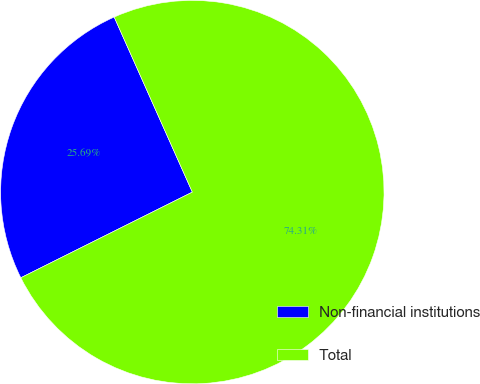Convert chart to OTSL. <chart><loc_0><loc_0><loc_500><loc_500><pie_chart><fcel>Non-financial institutions<fcel>Total<nl><fcel>25.69%<fcel>74.31%<nl></chart> 